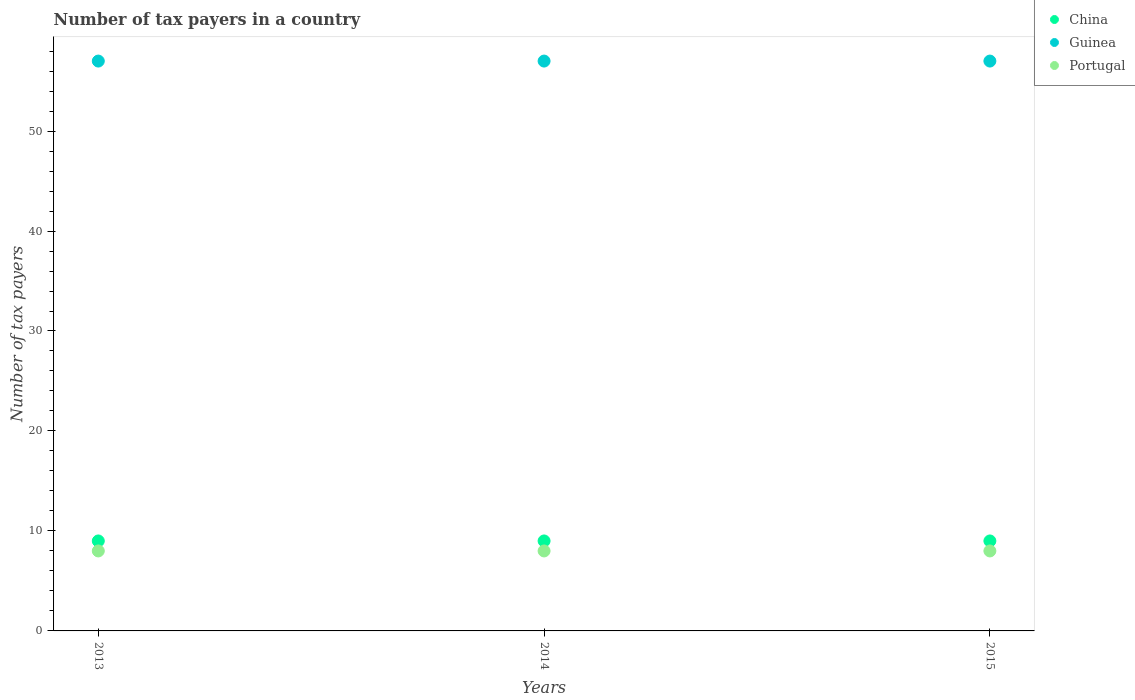How many different coloured dotlines are there?
Offer a very short reply. 3. What is the number of tax payers in in Guinea in 2015?
Offer a very short reply. 57. Across all years, what is the maximum number of tax payers in in China?
Offer a terse response. 9. Across all years, what is the minimum number of tax payers in in Portugal?
Your answer should be very brief. 8. In which year was the number of tax payers in in Guinea maximum?
Give a very brief answer. 2013. What is the total number of tax payers in in Guinea in the graph?
Provide a short and direct response. 171. What is the difference between the number of tax payers in in China in 2013 and that in 2014?
Your answer should be compact. 0. What is the difference between the number of tax payers in in Portugal in 2015 and the number of tax payers in in China in 2014?
Give a very brief answer. -1. In the year 2015, what is the difference between the number of tax payers in in China and number of tax payers in in Guinea?
Your response must be concise. -48. In how many years, is the number of tax payers in in Guinea greater than 26?
Provide a short and direct response. 3. What is the difference between the highest and the lowest number of tax payers in in Portugal?
Keep it short and to the point. 0. In how many years, is the number of tax payers in in Guinea greater than the average number of tax payers in in Guinea taken over all years?
Your response must be concise. 0. Is the sum of the number of tax payers in in China in 2014 and 2015 greater than the maximum number of tax payers in in Guinea across all years?
Your response must be concise. No. Does the number of tax payers in in Guinea monotonically increase over the years?
Your answer should be compact. No. Is the number of tax payers in in Portugal strictly greater than the number of tax payers in in China over the years?
Offer a terse response. No. What is the difference between two consecutive major ticks on the Y-axis?
Your response must be concise. 10. Does the graph contain grids?
Offer a terse response. No. Where does the legend appear in the graph?
Your answer should be compact. Top right. What is the title of the graph?
Keep it short and to the point. Number of tax payers in a country. Does "Trinidad and Tobago" appear as one of the legend labels in the graph?
Offer a terse response. No. What is the label or title of the Y-axis?
Give a very brief answer. Number of tax payers. What is the Number of tax payers of China in 2013?
Keep it short and to the point. 9. What is the Number of tax payers of Guinea in 2013?
Ensure brevity in your answer.  57. What is the Number of tax payers of Portugal in 2013?
Your answer should be compact. 8. What is the Number of tax payers of China in 2015?
Offer a terse response. 9. What is the Number of tax payers of Guinea in 2015?
Make the answer very short. 57. What is the Number of tax payers of Portugal in 2015?
Provide a short and direct response. 8. Across all years, what is the maximum Number of tax payers in Guinea?
Offer a terse response. 57. Across all years, what is the maximum Number of tax payers in Portugal?
Your answer should be very brief. 8. Across all years, what is the minimum Number of tax payers in China?
Your answer should be very brief. 9. Across all years, what is the minimum Number of tax payers in Guinea?
Provide a succinct answer. 57. What is the total Number of tax payers in Guinea in the graph?
Provide a short and direct response. 171. What is the total Number of tax payers in Portugal in the graph?
Offer a terse response. 24. What is the difference between the Number of tax payers in Guinea in 2013 and that in 2014?
Provide a short and direct response. 0. What is the difference between the Number of tax payers in China in 2013 and that in 2015?
Offer a very short reply. 0. What is the difference between the Number of tax payers of Guinea in 2013 and that in 2015?
Your answer should be compact. 0. What is the difference between the Number of tax payers of Portugal in 2013 and that in 2015?
Your answer should be very brief. 0. What is the difference between the Number of tax payers of China in 2014 and that in 2015?
Make the answer very short. 0. What is the difference between the Number of tax payers of Guinea in 2014 and that in 2015?
Keep it short and to the point. 0. What is the difference between the Number of tax payers of Portugal in 2014 and that in 2015?
Your response must be concise. 0. What is the difference between the Number of tax payers of China in 2013 and the Number of tax payers of Guinea in 2014?
Your response must be concise. -48. What is the difference between the Number of tax payers in China in 2013 and the Number of tax payers in Portugal in 2014?
Offer a very short reply. 1. What is the difference between the Number of tax payers of Guinea in 2013 and the Number of tax payers of Portugal in 2014?
Give a very brief answer. 49. What is the difference between the Number of tax payers of China in 2013 and the Number of tax payers of Guinea in 2015?
Offer a terse response. -48. What is the difference between the Number of tax payers in China in 2013 and the Number of tax payers in Portugal in 2015?
Your response must be concise. 1. What is the difference between the Number of tax payers in Guinea in 2013 and the Number of tax payers in Portugal in 2015?
Keep it short and to the point. 49. What is the difference between the Number of tax payers of China in 2014 and the Number of tax payers of Guinea in 2015?
Make the answer very short. -48. What is the difference between the Number of tax payers of China in 2014 and the Number of tax payers of Portugal in 2015?
Offer a terse response. 1. In the year 2013, what is the difference between the Number of tax payers of China and Number of tax payers of Guinea?
Your answer should be compact. -48. In the year 2013, what is the difference between the Number of tax payers of China and Number of tax payers of Portugal?
Provide a succinct answer. 1. In the year 2014, what is the difference between the Number of tax payers in China and Number of tax payers in Guinea?
Keep it short and to the point. -48. In the year 2015, what is the difference between the Number of tax payers in China and Number of tax payers in Guinea?
Provide a short and direct response. -48. In the year 2015, what is the difference between the Number of tax payers of China and Number of tax payers of Portugal?
Make the answer very short. 1. What is the ratio of the Number of tax payers in China in 2013 to that in 2014?
Offer a very short reply. 1. What is the ratio of the Number of tax payers of China in 2013 to that in 2015?
Give a very brief answer. 1. What is the ratio of the Number of tax payers in Portugal in 2014 to that in 2015?
Your answer should be compact. 1. What is the difference between the highest and the second highest Number of tax payers of Guinea?
Your answer should be very brief. 0. What is the difference between the highest and the second highest Number of tax payers in Portugal?
Offer a very short reply. 0. 